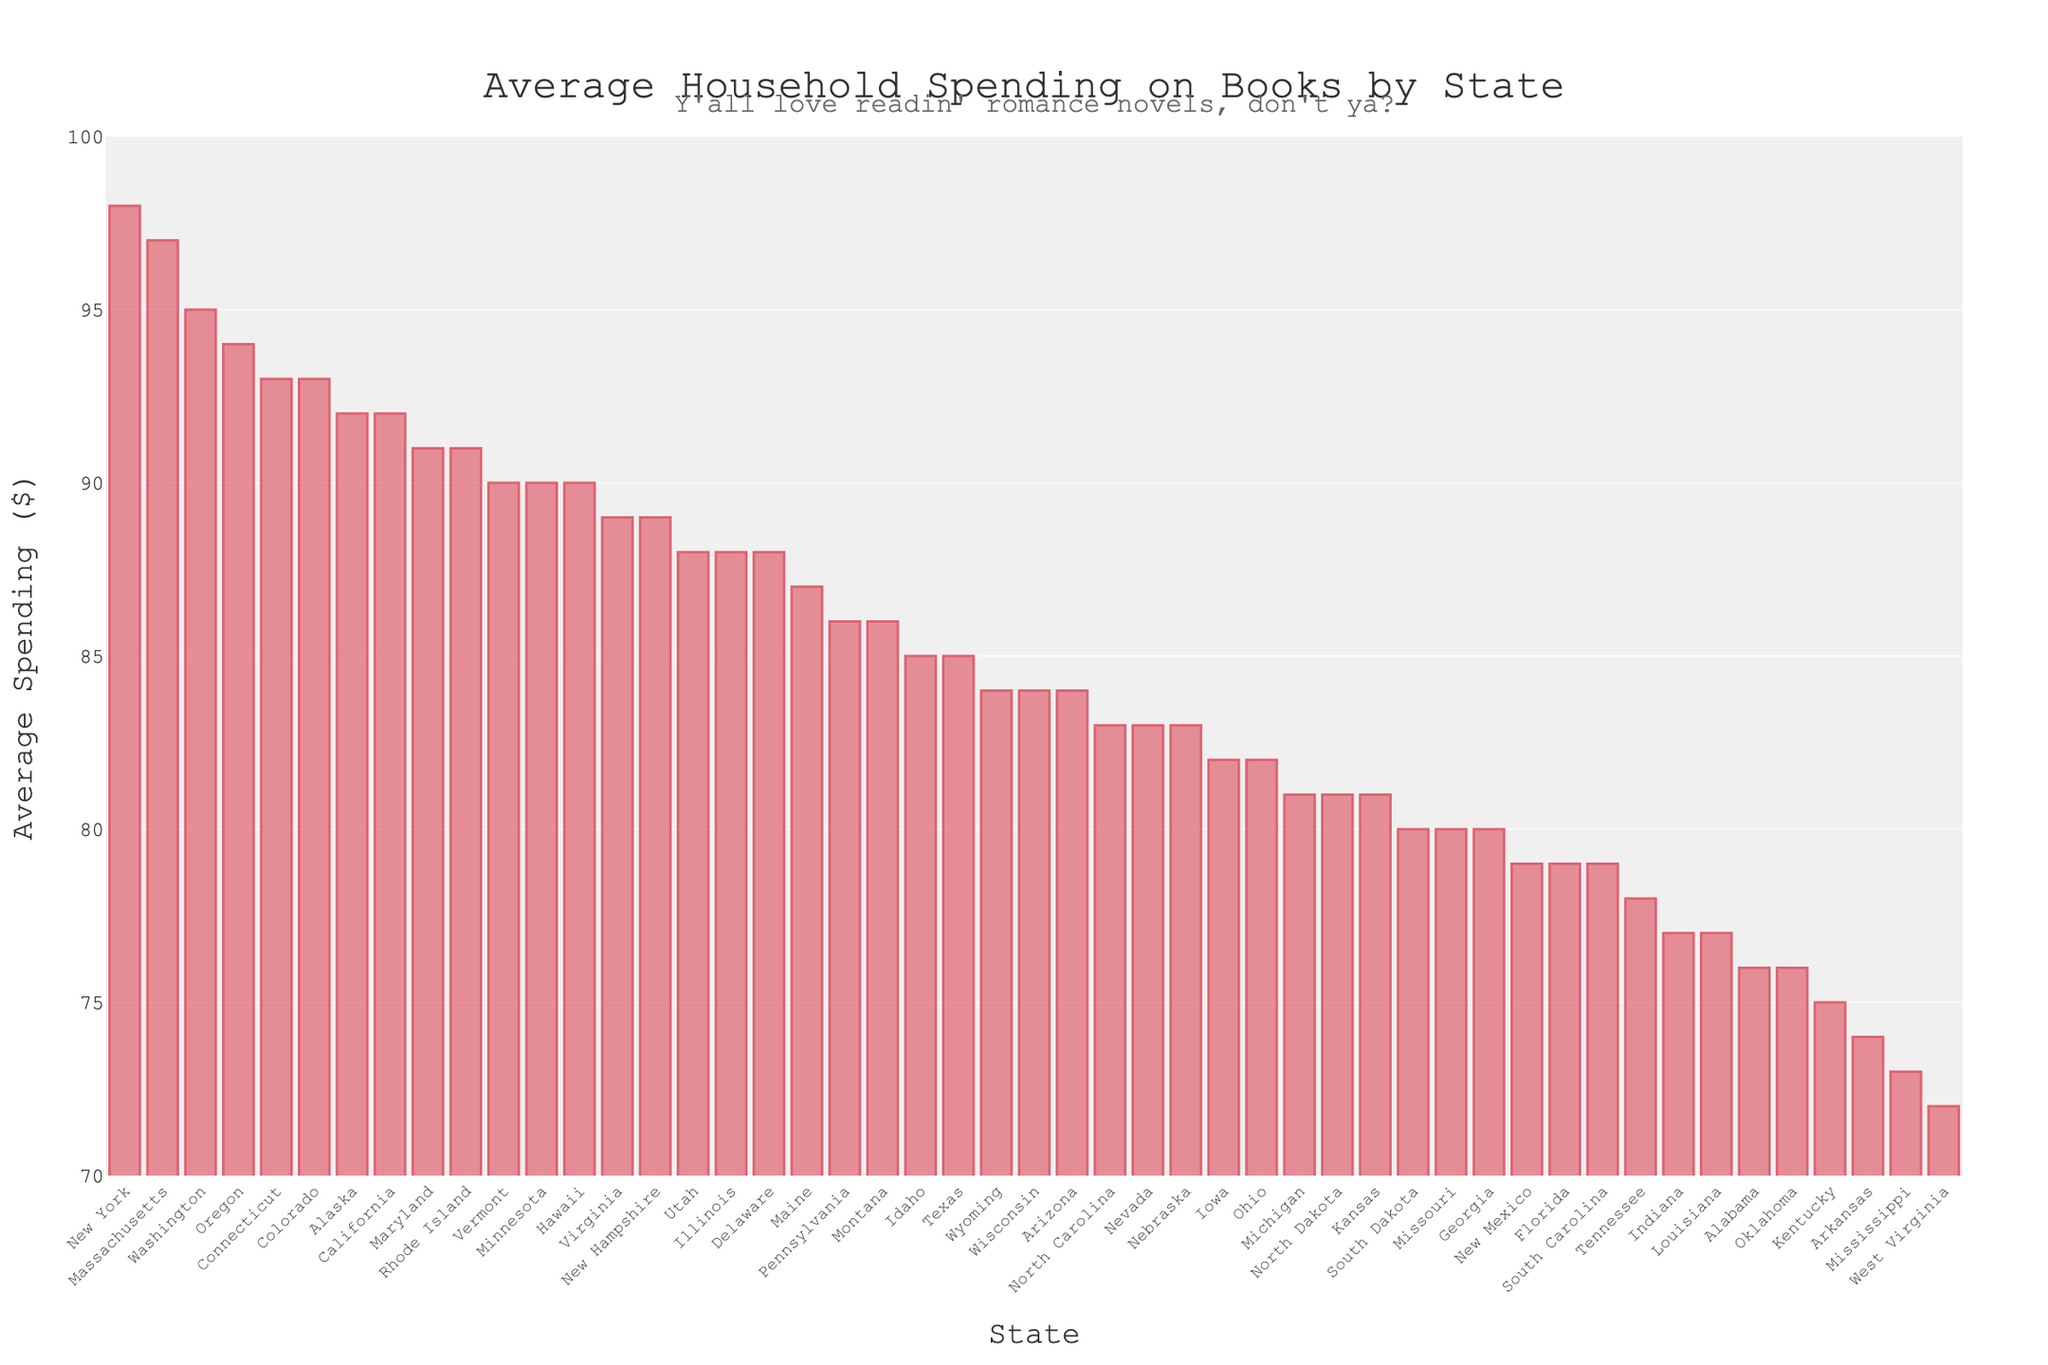Which state has the highest average household spending on books? The highest bar in the chart represents New York, which has the largest spending value.
Answer: New York How much more does California spend on books compared to Alabama? Find the values for California and Alabama. California spends $92, while Alabama spends $76. The difference is $92 - $76 = $16.
Answer: $16 What is the total average household spending on books for Texas, California, and New York combined? Sum the spending values for Texas ($85), California ($92), and New York ($98). The total is $85 + $92 + $98 = $275.
Answer: $275 Which states have a higher average household spending on books than Texas? Identify states with spending values greater than $85. They are California, New York, Illinois, Virginia, Washington, Massachusetts, Maryland, Colorado, and Connecticut.
Answer: California, New York, Illinois, Virginia, Washington, Massachusetts, Maryland, Colorado, Connecticut What is the average household spending on books for the bottom three states? Identify the three states with the lowest spending: Mississippi ($73), West Virginia ($72), and Arkansas ($74), and calculate the average. (73 + 72 + 74) / 3 = 73.
Answer: 73 Are there any states with the same average household spending on books? Look for bars of equal height. Indiana and Louisiana both have $77; North Carolina and Nevada both have $83; Arizona and Wisconsin both have $84.
Answer: Indiana, Louisiana; North Carolina, Nevada; Arizona, Wisconsin Which state spends exactly $90 on books, and how many states spend more than $90? Identify the state that spends $90, which is Minnesota, Hawaii, and Vermont, and count the number of bars higher than $90: New York, Massachusetts, Washington.
Answer: Minnesota, Hawaii, Vermont; 3 Compare the average household spending on books between Florida and Oregon. Which state spends more, and by how much? Florida spends $79, and Oregon spends $94. Oregon spends more by $94 - $79 = $15.
Answer: Oregon, $15 Is the average spending on books in Georgia closer to that of Florida or Massachusetts? Compare the values. Georgia spends $80, Florida spends $79, and Massachusetts spends $97. The difference with Florida is $1 (80-79), and with Massachusetts is $17 (97-80).
Answer: Florida 